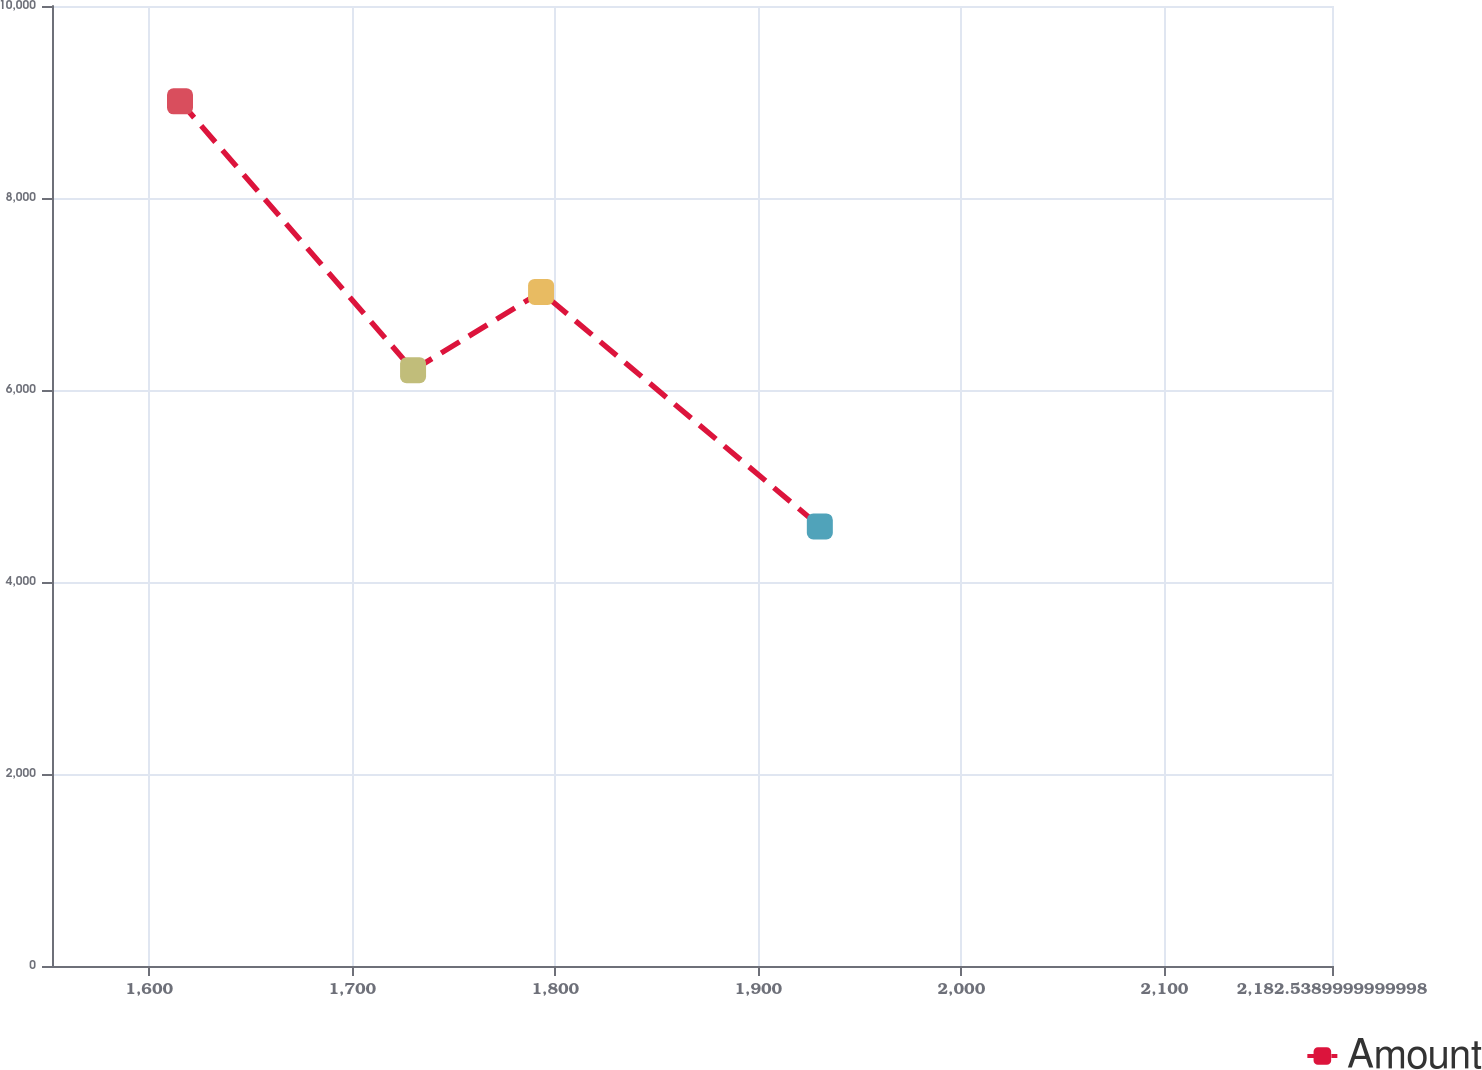Convert chart. <chart><loc_0><loc_0><loc_500><loc_500><line_chart><ecel><fcel>Amount<nl><fcel>1615.17<fcel>9007.25<nl><fcel>1729.96<fcel>6206.27<nl><fcel>1793<fcel>7021.35<nl><fcel>1930.29<fcel>4579.37<nl><fcel>2245.58<fcel>5159.78<nl></chart> 